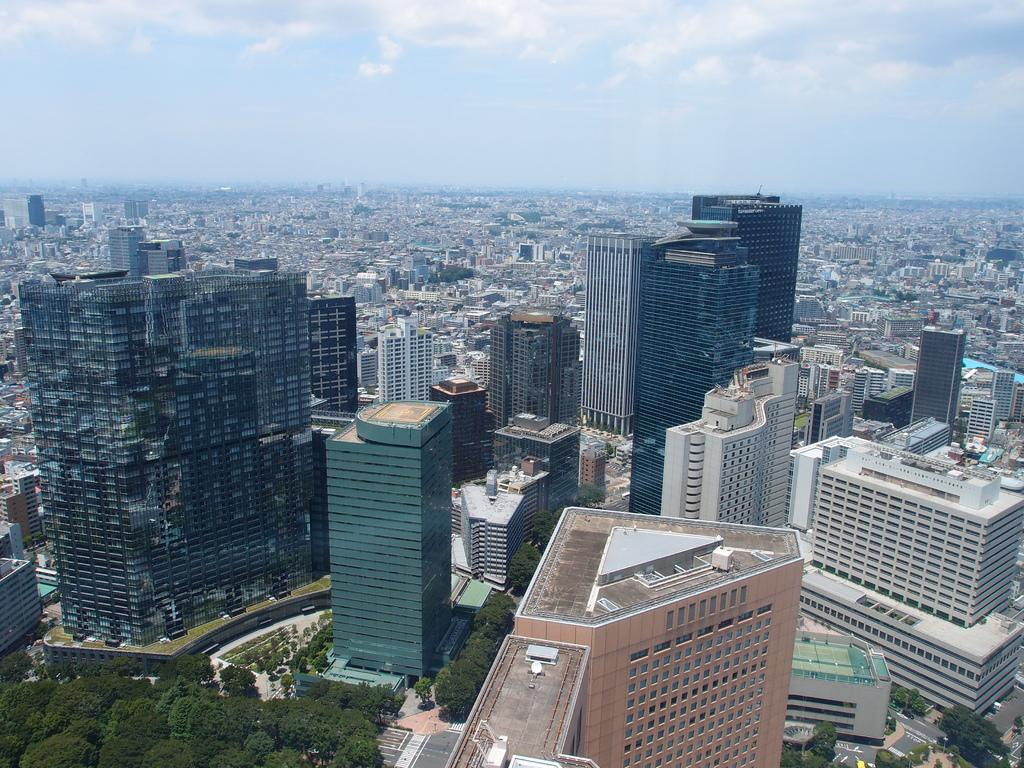What type of structures can be seen in the image? There are buildings in the image. What other natural elements are present in the image? There are trees in the image. What is visible at the top of the image? The sky is visible at the top of the image. What can be observed in the sky? Clouds are present in the sky. What type of vegetable is growing in the cemetery in the image? There is no cemetery or vegetable present in the image. How many pears can be seen hanging from the trees in the image? There are no pears visible in the image; only trees are present. 